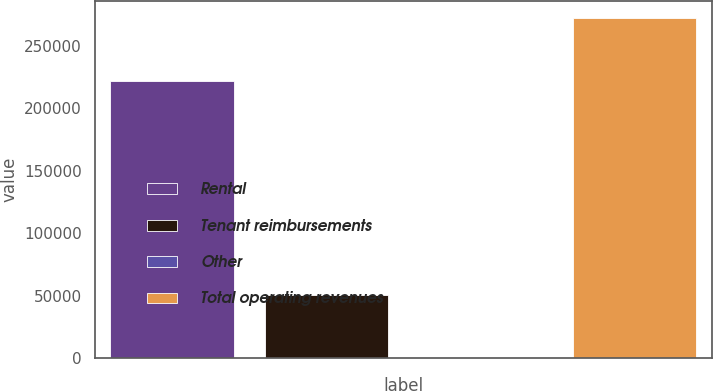<chart> <loc_0><loc_0><loc_500><loc_500><bar_chart><fcel>Rental<fcel>Tenant reimbursements<fcel>Other<fcel>Total operating revenues<nl><fcel>221371<fcel>50340<fcel>365<fcel>272076<nl></chart> 